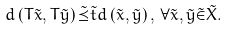<formula> <loc_0><loc_0><loc_500><loc_500>d \left ( T \tilde { x } , T \tilde { y } \right ) \tilde { \preceq } \tilde { t } d \left ( \tilde { x } , \tilde { y } \right ) , \, \forall \tilde { x } , \tilde { y } \tilde { \in } \tilde { X } .</formula> 